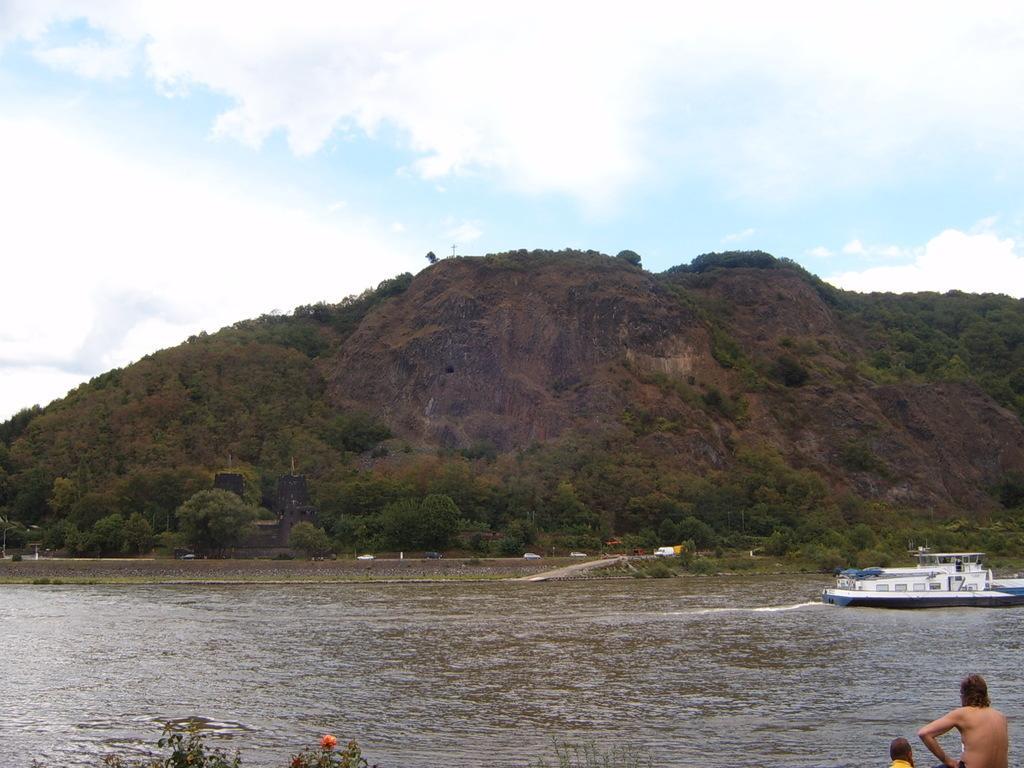Please provide a concise description of this image. In this picture a boat sailing on the water and I can see couple of humans, trees, hill and a blue cloudy sky. 